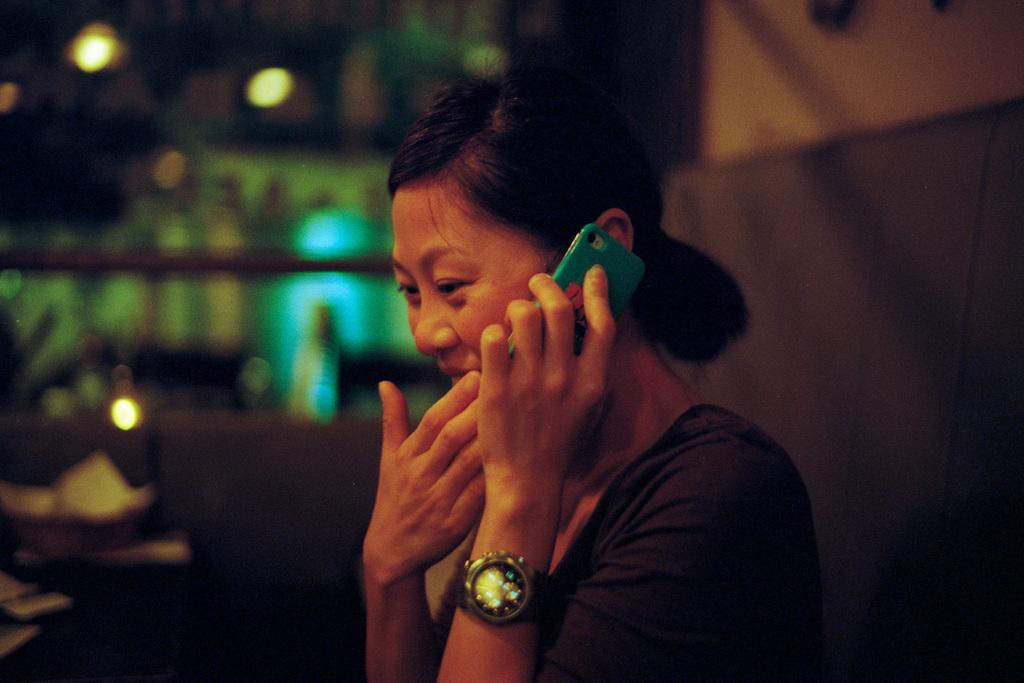Who is the main subject in the image? There is a woman in the image. What is the woman holding in the image? The woman is holding a mobile. What accessory is the woman wearing in the image? The woman is wearing a watch. Can you describe the background of the image? The background of the image is blurry. What can be seen in the image that provides illumination? There are lights visible in the image. What type of shoe is the woman wearing in the image? There is no shoe visible in the image; the woman is not wearing any footwear. What subject is the woman teaching in the image? There is no indication of a class or teaching in the image; the woman is simply holding a mobile. 